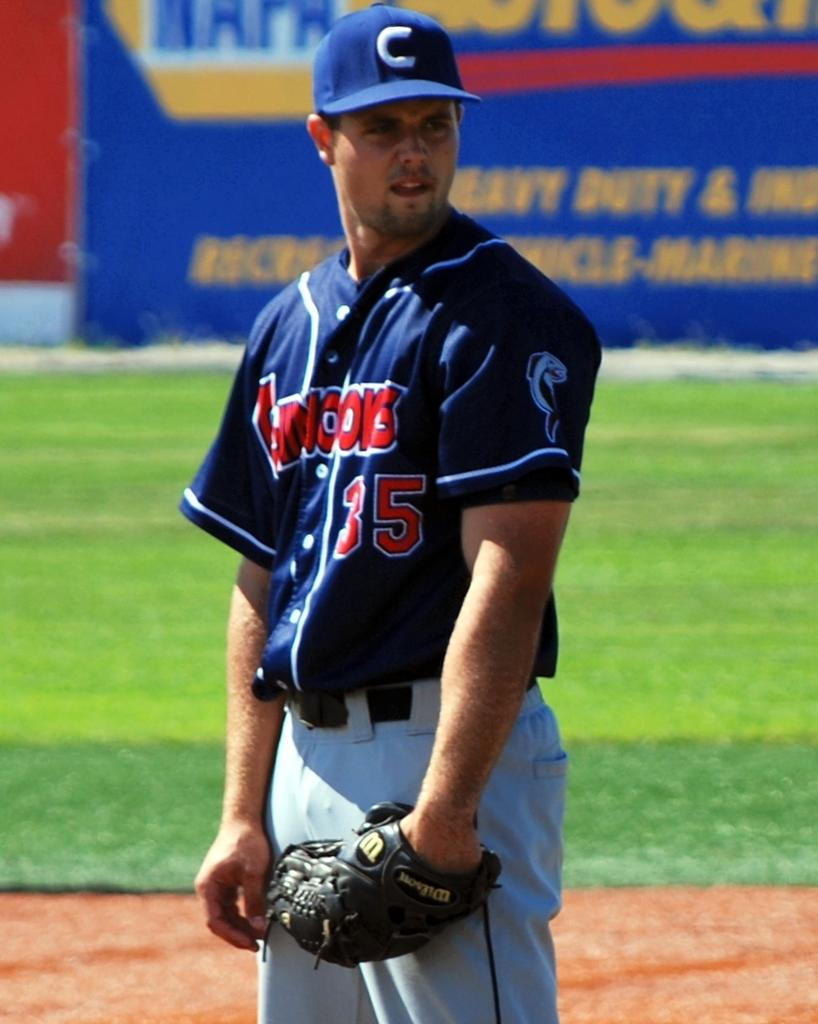Provide a one-sentence caption for the provided image. A baseball player stands on the field with a NAPA ad behind him. 